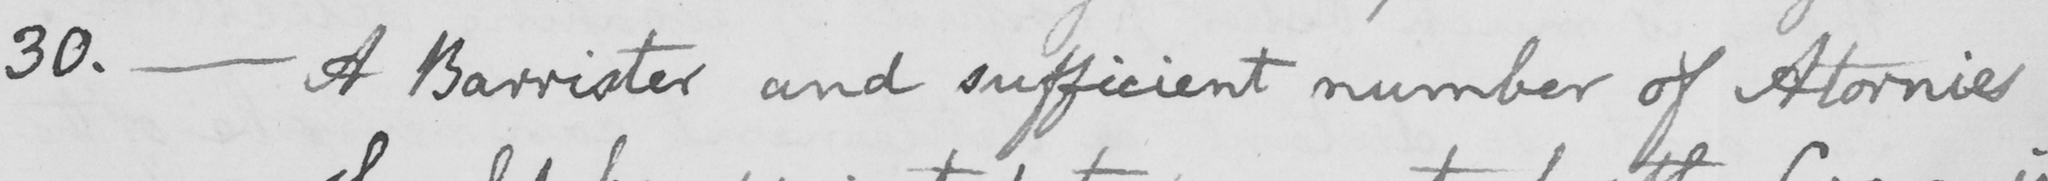Please provide the text content of this handwritten line. 30. _ A Barrister and sufficient number of Atornies 